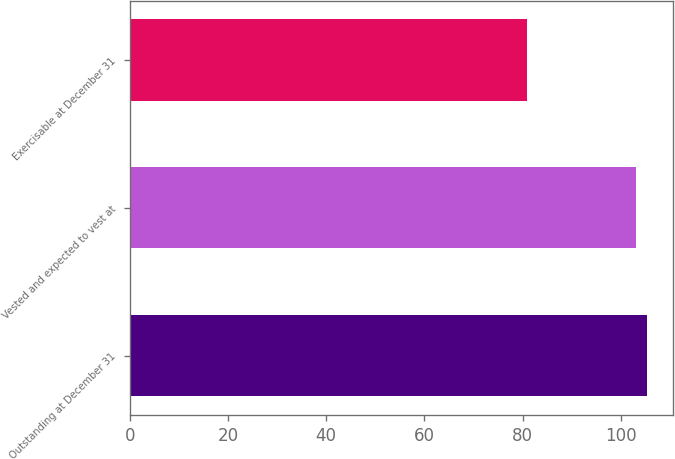Convert chart to OTSL. <chart><loc_0><loc_0><loc_500><loc_500><bar_chart><fcel>Outstanding at December 31<fcel>Vested and expected to vest at<fcel>Exercisable at December 31<nl><fcel>105.28<fcel>103.01<fcel>80.81<nl></chart> 